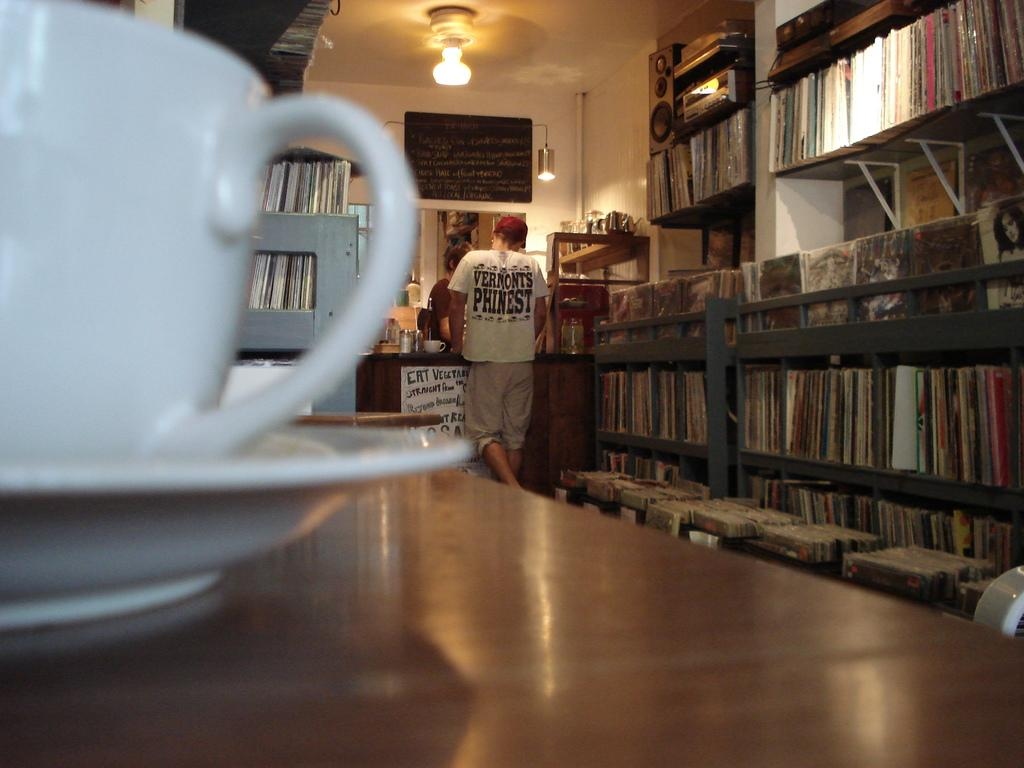<image>
Offer a succinct explanation of the picture presented. Man wearing a white shirt that says "Vermont's Phinest" inside a store. 